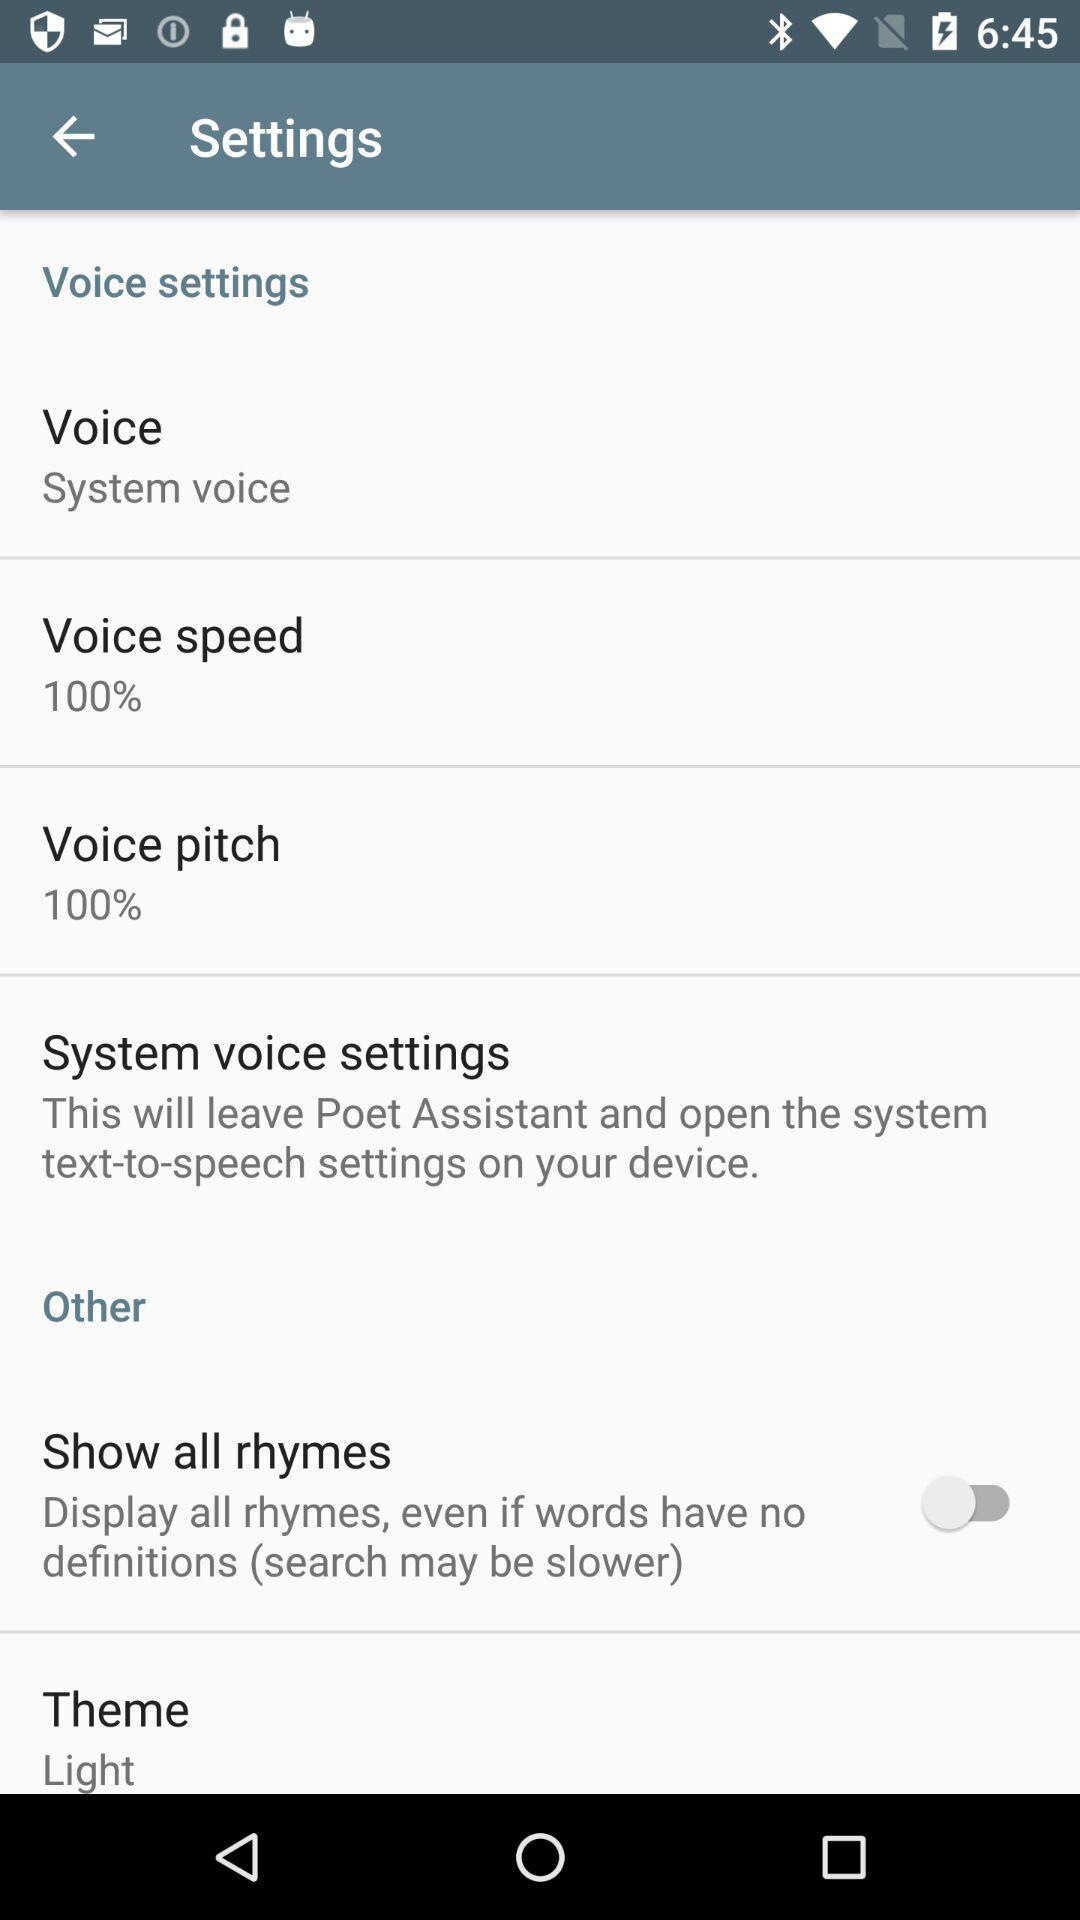What is the setting for voice speed? The setting for voice speed is "100%". 